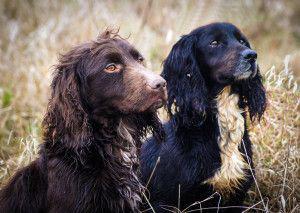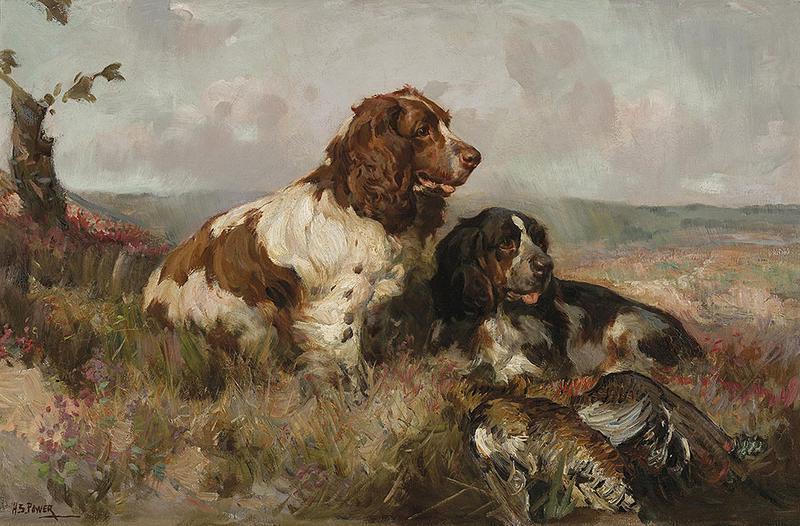The first image is the image on the left, the second image is the image on the right. Given the left and right images, does the statement "All of the dogs are black." hold true? Answer yes or no. No. The first image is the image on the left, the second image is the image on the right. Assess this claim about the two images: "All images show only dogs with black fur on their faces.". Correct or not? Answer yes or no. No. 